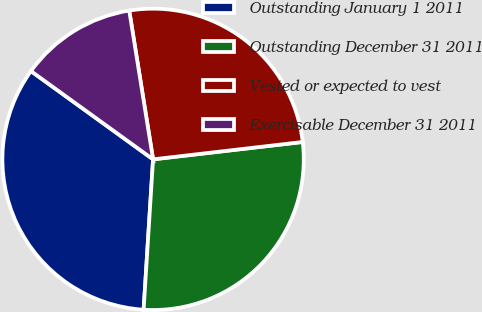Convert chart. <chart><loc_0><loc_0><loc_500><loc_500><pie_chart><fcel>Outstanding January 1 2011<fcel>Outstanding December 31 2011<fcel>Vested or expected to vest<fcel>Exercisable December 31 2011<nl><fcel>33.96%<fcel>27.84%<fcel>25.69%<fcel>12.51%<nl></chart> 